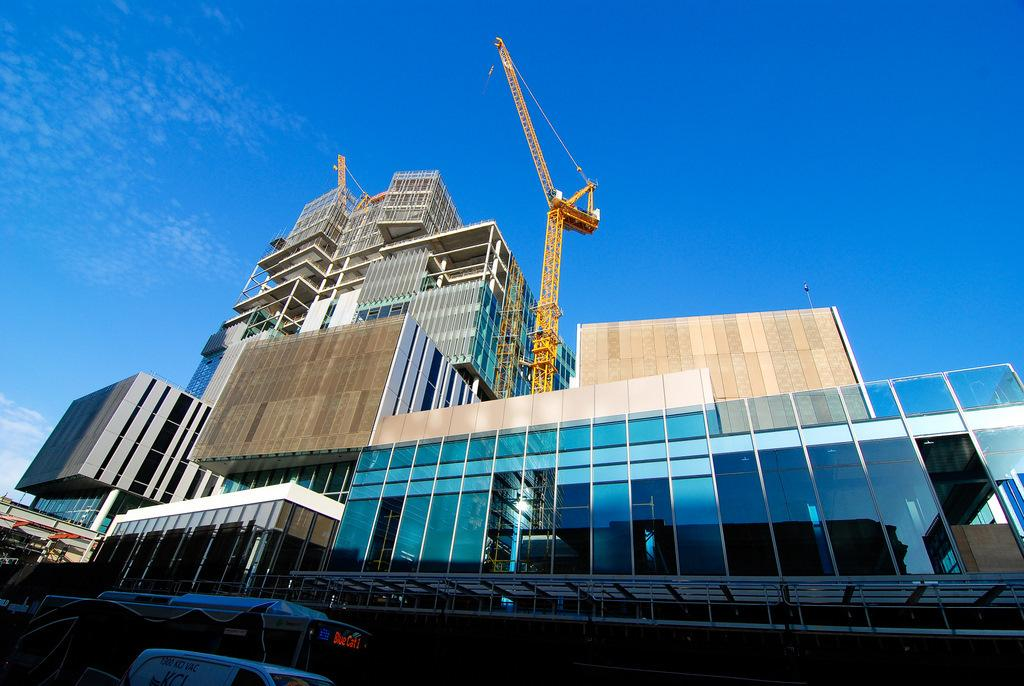What is the main subject of the image? There is a vehicle in the image. Where is the vehicle located in the image? The vehicle is at the bottom of the image. What else can be seen in the image besides the vehicle? There are buildings, glasses, cranes, and clouds in the sky in the image. Can you see any ducks flying in the sky in the image? There are no ducks present in the image; it only features a vehicle, buildings, glasses, cranes, and clouds in the sky. 